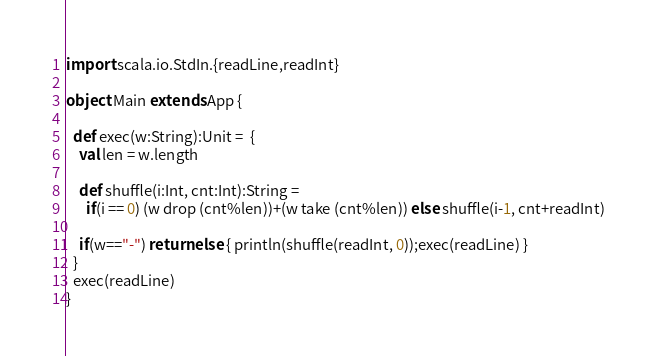<code> <loc_0><loc_0><loc_500><loc_500><_Scala_>import scala.io.StdIn.{readLine,readInt}

object Main extends App {

  def exec(w:String):Unit =  {
    val len = w.length

    def shuffle(i:Int, cnt:Int):String =
      if(i == 0) (w drop (cnt%len))+(w take (cnt%len)) else shuffle(i-1, cnt+readInt)

    if(w=="-") return else { println(shuffle(readInt, 0));exec(readLine) }
  }
  exec(readLine)
}</code> 